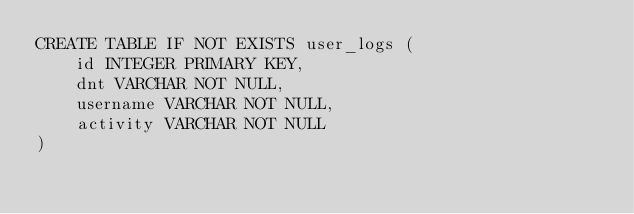<code> <loc_0><loc_0><loc_500><loc_500><_SQL_>CREATE TABLE IF NOT EXISTS user_logs (
	id INTEGER PRIMARY KEY,
	dnt VARCHAR NOT NULL,
    username VARCHAR NOT NULL,
    activity VARCHAR NOT NULL
)
</code> 